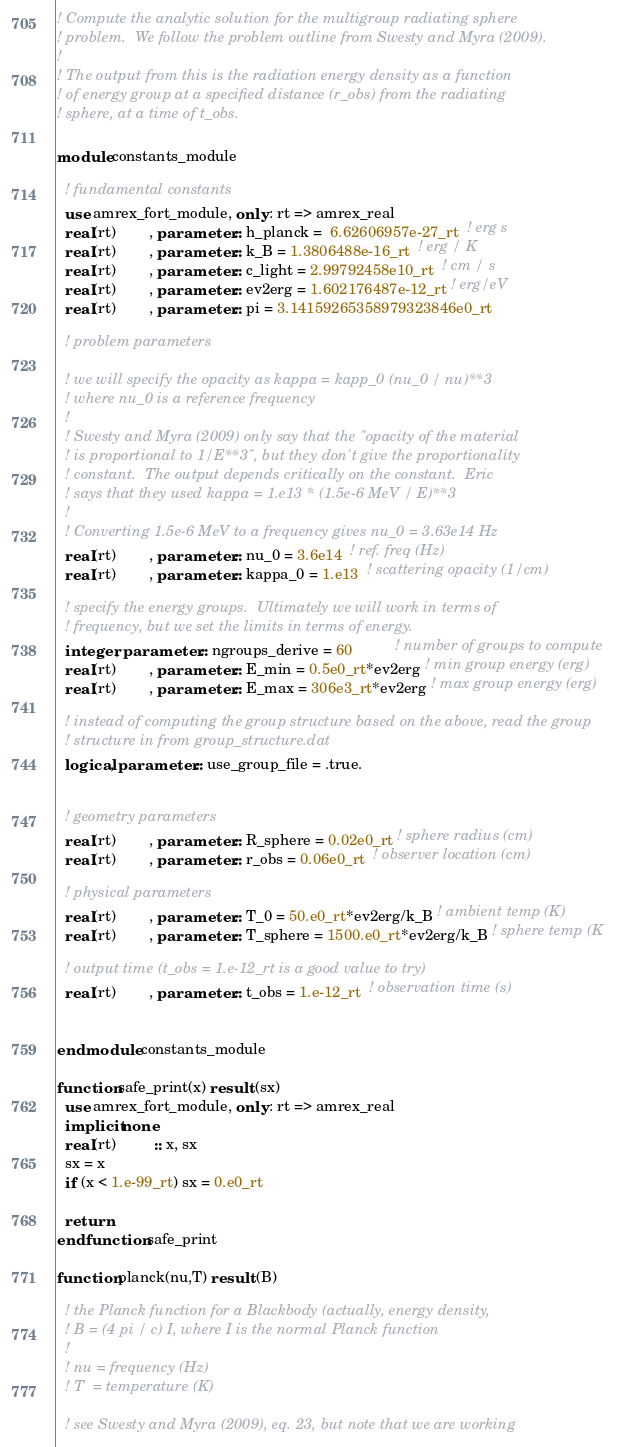<code> <loc_0><loc_0><loc_500><loc_500><_FORTRAN_>! Compute the analytic solution for the multigroup radiating sphere
! problem.  We follow the problem outline from Swesty and Myra (2009).
!
! The output from this is the radiation energy density as a function
! of energy group at a specified distance (r_obs) from the radiating
! sphere, at a time of t_obs.

module constants_module

  ! fundamental constants
  use amrex_fort_module, only : rt => amrex_real
  real(rt)        , parameter :: h_planck =  6.62606957e-27_rt  ! erg s
  real(rt)        , parameter :: k_B = 1.3806488e-16_rt  ! erg / K
  real(rt)        , parameter :: c_light = 2.99792458e10_rt  ! cm / s
  real(rt)        , parameter :: ev2erg = 1.602176487e-12_rt ! erg/eV
  real(rt)        , parameter :: pi = 3.14159265358979323846e0_rt

  ! problem parameters

  ! we will specify the opacity as kappa = kapp_0 (nu_0 / nu)**3
  ! where nu_0 is a reference frequency
  ! 
  ! Swesty and Myra (2009) only say that the "opacity of the material
  ! is proportional to 1/E**3", but they don't give the proportionality
  ! constant.  The output depends critically on the constant.  Eric
  ! says that they used kappa = 1.e13 * (1.5e-6 MeV / E)**3
  !
  ! Converting 1.5e-6 MeV to a frequency gives nu_0 = 3.63e14 Hz
  real(rt)        , parameter :: nu_0 = 3.6e14  ! ref. freq (Hz)
  real(rt)        , parameter :: kappa_0 = 1.e13  ! scattering opacity (1/cm)

  ! specify the energy groups.  Ultimately we will work in terms of 
  ! frequency, but we set the limits in terms of energy.  
  integer, parameter :: ngroups_derive = 60          ! number of groups to compute
  real(rt)        , parameter :: E_min = 0.5e0_rt*ev2erg ! min group energy (erg)
  real(rt)        , parameter :: E_max = 306e3_rt*ev2erg ! max group energy (erg)

  ! instead of computing the group structure based on the above, read the group
  ! structure in from group_structure.dat
  logical, parameter :: use_group_file = .true.


  ! geometry parameters
  real(rt)        , parameter :: R_sphere = 0.02e0_rt ! sphere radius (cm)
  real(rt)        , parameter :: r_obs = 0.06e0_rt  ! observer location (cm)

  ! physical parameters
  real(rt)        , parameter :: T_0 = 50.e0_rt*ev2erg/k_B ! ambient temp (K)
  real(rt)        , parameter :: T_sphere = 1500.e0_rt*ev2erg/k_B ! sphere temp (K
  
  ! output time (t_obs = 1.e-12_rt is a good value to try)
  real(rt)        , parameter :: t_obs = 1.e-12_rt  ! observation time (s)


end module constants_module

function safe_print(x) result (sx)
  use amrex_fort_module, only : rt => amrex_real
  implicit none
  real(rt)         :: x, sx
  sx = x
  if (x < 1.e-99_rt) sx = 0.e0_rt

  return
end function safe_print

function planck(nu,T) result (B)

  ! the Planck function for a Blackbody (actually, energy density,
  ! B = (4 pi / c) I, where I is the normal Planck function
  ! 
  ! nu = frequency (Hz)
  ! T  = temperature (K)

  ! see Swesty and Myra (2009), eq. 23, but note that we are working</code> 